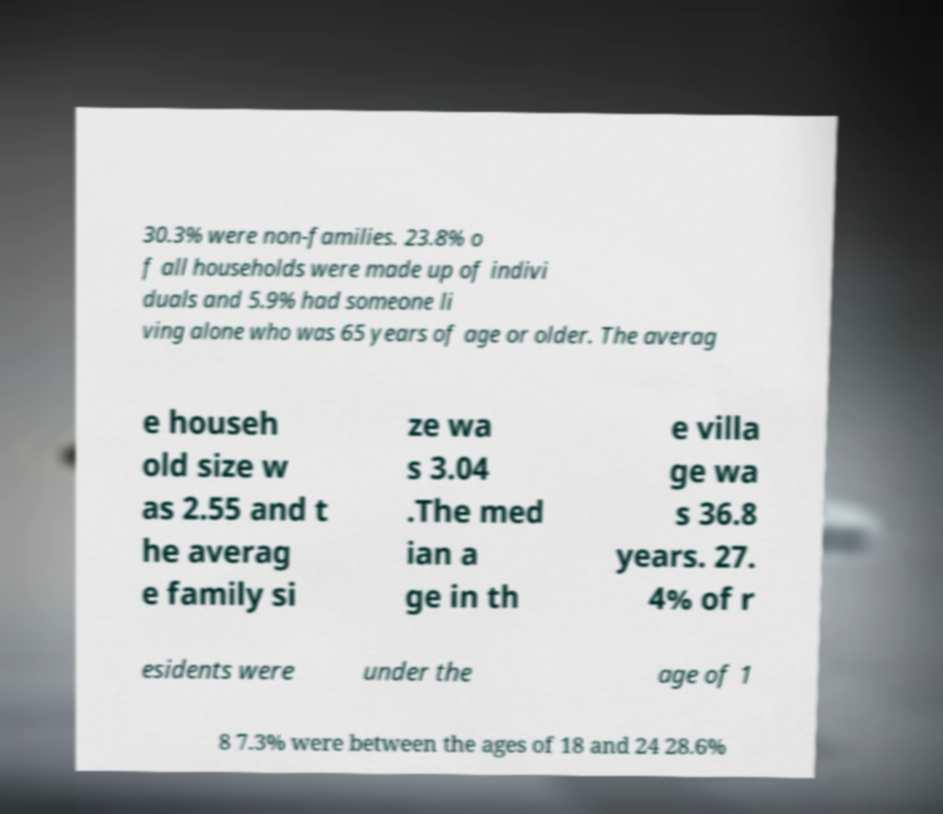What messages or text are displayed in this image? I need them in a readable, typed format. 30.3% were non-families. 23.8% o f all households were made up of indivi duals and 5.9% had someone li ving alone who was 65 years of age or older. The averag e househ old size w as 2.55 and t he averag e family si ze wa s 3.04 .The med ian a ge in th e villa ge wa s 36.8 years. 27. 4% of r esidents were under the age of 1 8 7.3% were between the ages of 18 and 24 28.6% 